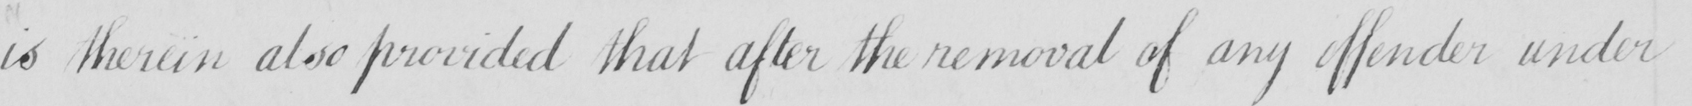Transcribe the text shown in this historical manuscript line. is therein also provided that after the removal of any offender under 